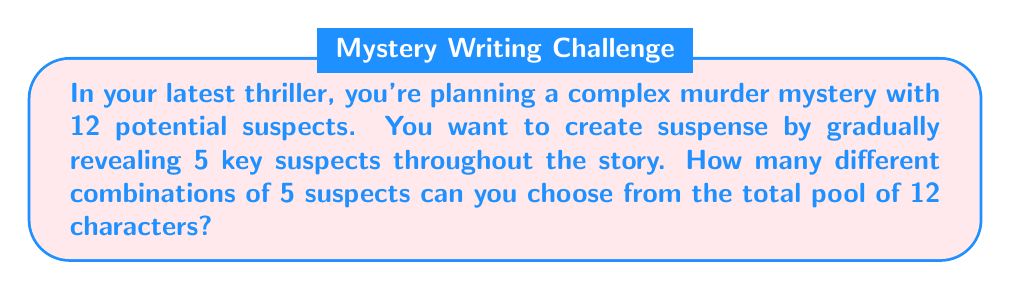Can you answer this question? Let's approach this step-by-step:

1) This is a combination problem. We're selecting 5 suspects from a group of 12, where the order doesn't matter (it's not important which suspect is revealed first, second, etc.).

2) The formula for combinations is:

   $$C(n,r) = \frac{n!}{r!(n-r)!}$$

   Where $n$ is the total number of items to choose from, and $r$ is the number of items being chosen.

3) In this case, $n = 12$ (total suspects) and $r = 5$ (key suspects to be revealed).

4) Let's substitute these values into our formula:

   $$C(12,5) = \frac{12!}{5!(12-5)!} = \frac{12!}{5!(7)!}$$

5) Expand this:
   $$\frac{12 * 11 * 10 * 9 * 8 * 7!}{(5 * 4 * 3 * 2 * 1) * 7!}$$

6) The 7! cancels out in the numerator and denominator:

   $$\frac{12 * 11 * 10 * 9 * 8}{5 * 4 * 3 * 2 * 1}$$

7) Multiply the numerator and denominator:

   $$\frac{95040}{120} = 792$$

Therefore, there are 792 different ways to choose 5 key suspects from a pool of 12 characters.
Answer: 792 